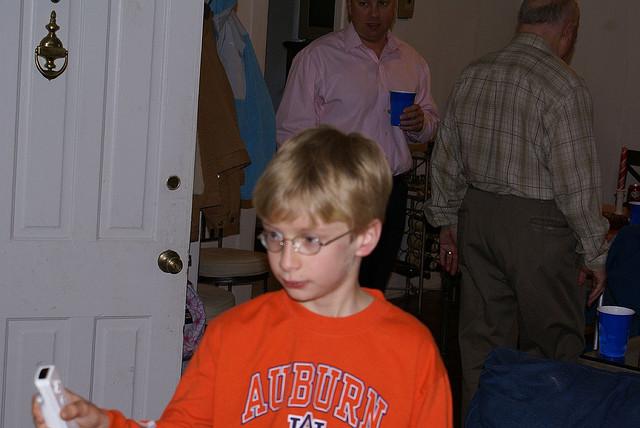What team is on the boy's shirt?
Keep it brief. Auburn. What does the boy have on his eyes?
Concise answer only. Glasses. What kind of controller is the boy holding?
Short answer required. Wii. 